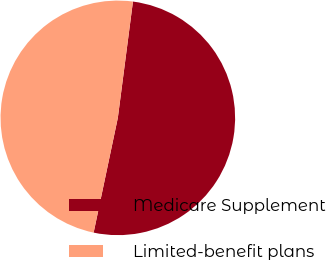<chart> <loc_0><loc_0><loc_500><loc_500><pie_chart><fcel>Medicare Supplement<fcel>Limited-benefit plans<nl><fcel>51.25%<fcel>48.75%<nl></chart> 